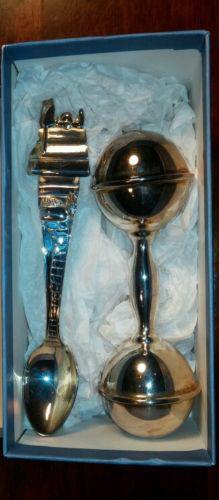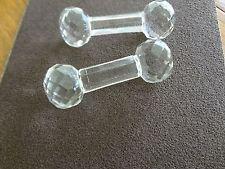The first image is the image on the left, the second image is the image on the right. For the images shown, is this caption "There is a knife, fork, and spoon in the image on the right." true? Answer yes or no. No. 